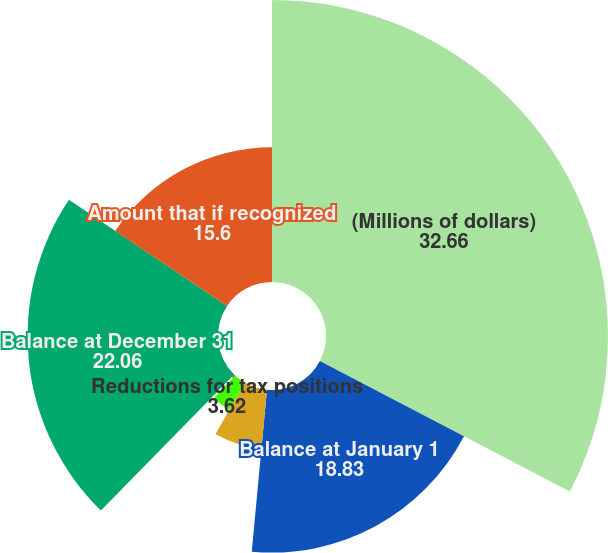Convert chart. <chart><loc_0><loc_0><loc_500><loc_500><pie_chart><fcel>(Millions of dollars)<fcel>Balance at January 1<fcel>Additions for tax positions<fcel>Reductions for tax positions<fcel>Reductions for settlements 2<fcel>Balance at December 31<fcel>Amount that if recognized<nl><fcel>32.66%<fcel>18.83%<fcel>6.84%<fcel>3.62%<fcel>0.39%<fcel>22.06%<fcel>15.6%<nl></chart> 